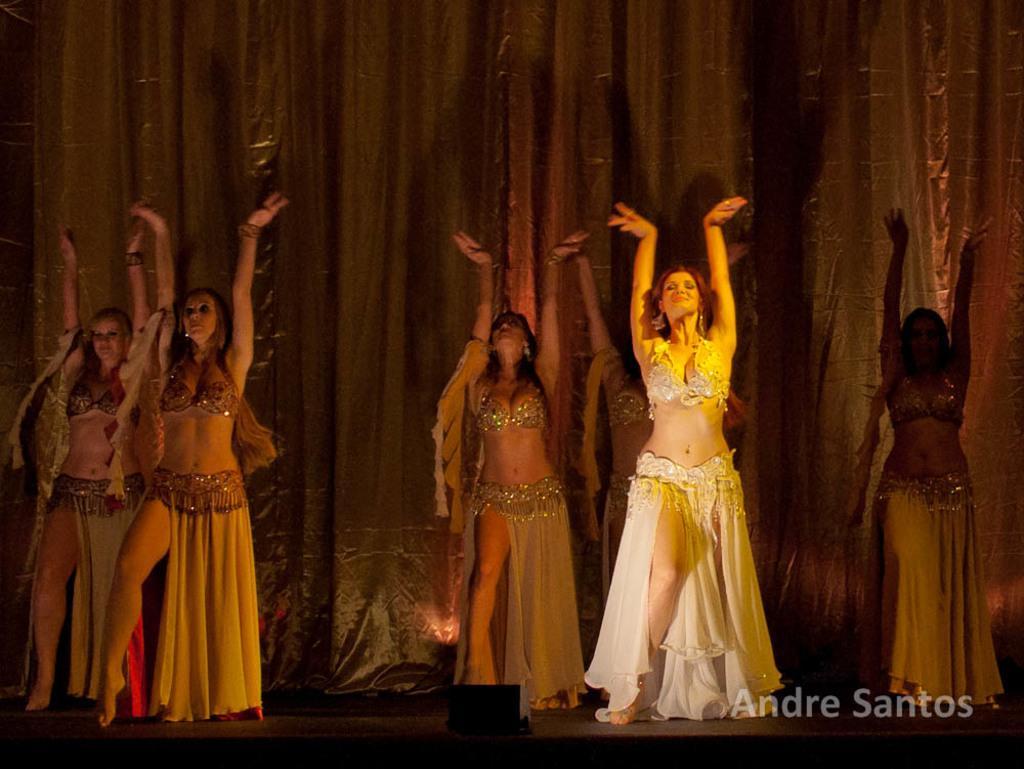How would you summarize this image in a sentence or two? In this image I see 6 women who are wearing same costumes and I see the watermark over here. In the background I see the curtain. 